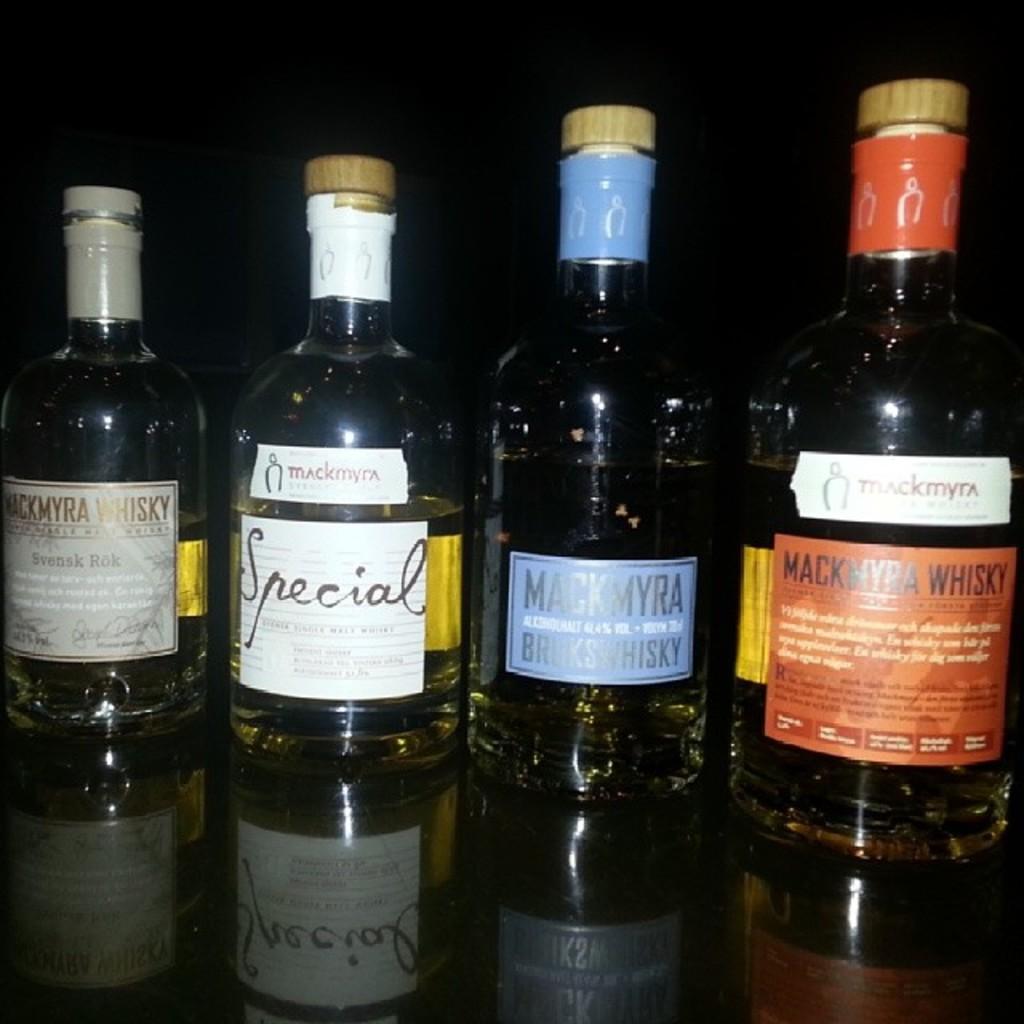What is the brand of red bottle?
Your answer should be compact. Mackmyra whisky. 